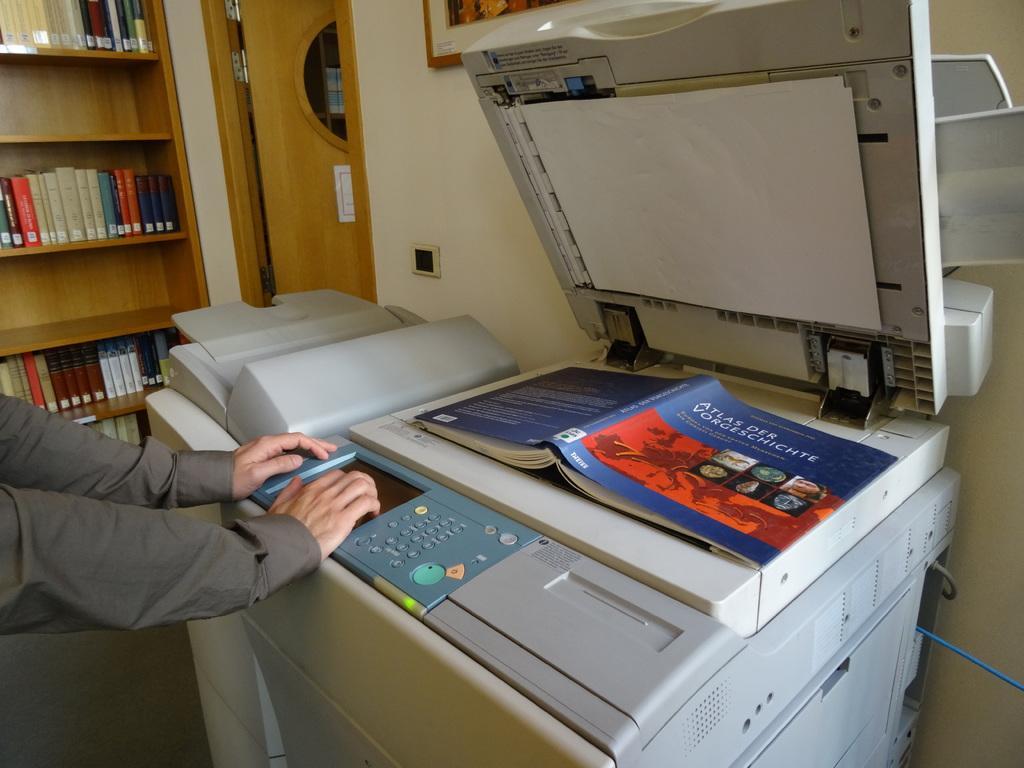How would you summarize this image in a sentence or two? This picture is taken inside the room. In this image, on the left side, we can see the hand of a person keeping on the electronic machine. On the right side, we can see an electronic machine, on the machine, we can see a book. In the background, we can see some books on the shelf, photo frame which is attached to a wall and a door. 